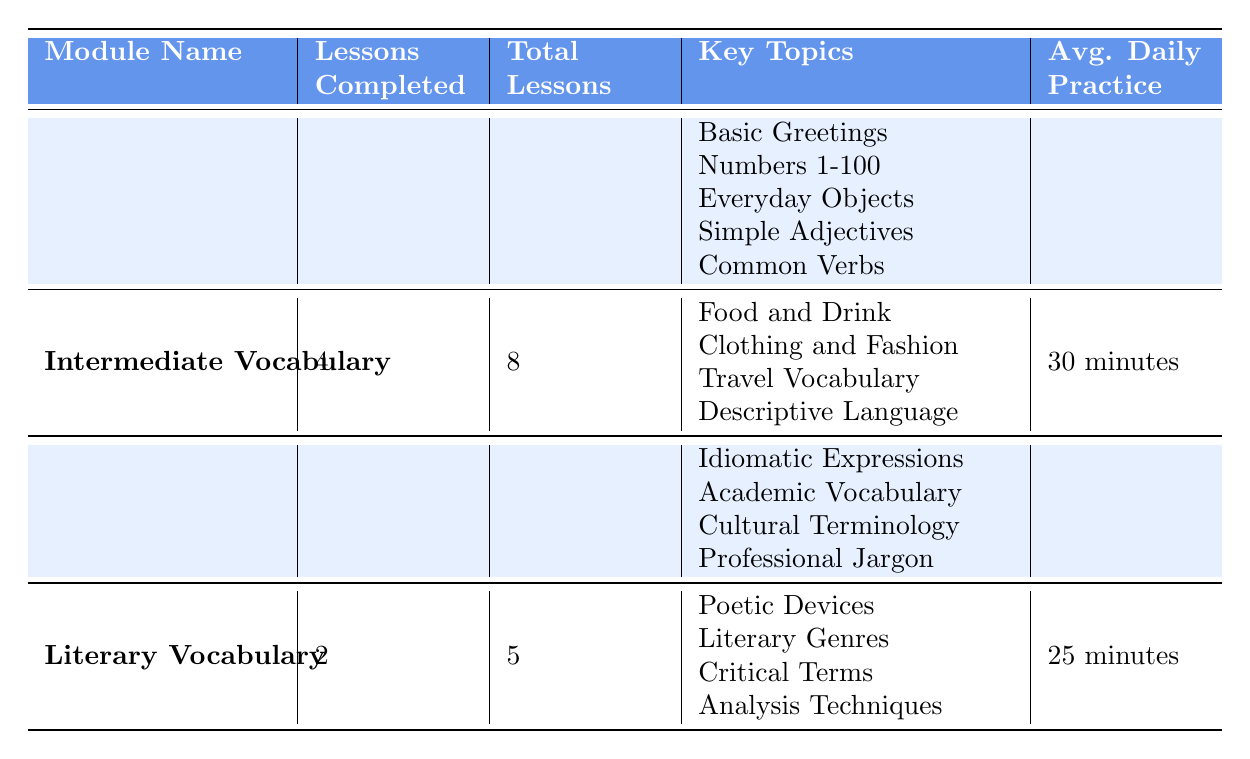What is the average daily practice time for the Intermediate Vocabulary module? The average daily practice time is explicitly stated in the table under the "Avg. Daily Practice" column for the Intermediate Vocabulary module. It shows "30 minutes."
Answer: 30 minutes How many total lessons are there in the Basic Vocabulary module? The total number of lessons for the Basic Vocabulary module is provided in the "Total Lessons" column. The table shows that there are 10 total lessons.
Answer: 10 Which module has the least number of lessons completed? To determine this, we compare the "Lessons Completed" for each module. The table shows Basic Vocabulary with 5, Intermediate Vocabulary with 4, Advanced Vocabulary with 3, and Literary Vocabulary with 2. Therefore, Literary Vocabulary has the least.
Answer: Literary Vocabulary What is the total number of lessons completed across all modules? First, we sum the "Lessons Completed" from each module: 5 (Basic) + 4 (Intermediate) + 3 (Advanced) + 2 (Literary) = 14. Therefore, the total number of lessons completed is 14.
Answer: 14 Is the average daily practice for the Advanced Vocabulary module greater than that for the Basic Vocabulary module? The average daily practice times are compared: Advanced Vocabulary has "40 minutes" and Basic Vocabulary has "20 minutes." Since 40 minutes is greater than 20 minutes, the statement is true.
Answer: Yes Which module covers the topic of "Cultural Terminology"? Looking through the "Key Topics" for each module, "Cultural Terminology" is a topic listed under the Advanced Vocabulary module in the table.
Answer: Advanced Vocabulary If a learner practices every module for its average daily practice time, how many total minutes do they practice in a day? We calculate the total practice time by adding the average daily practice for each module: 20 (Basic) + 30 (Intermediate) + 40 (Advanced) + 25 (Literary) = 115 minutes. Thus, the total daily practice time is 115 minutes.
Answer: 115 minutes Is it true that all modules have at least 4 lessons completed? By examining the "Lessons Completed" for each module, we find that the Literary Vocabulary module has only 2 completed lessons, therefore confirming that not all modules meet the criterion.
Answer: No 